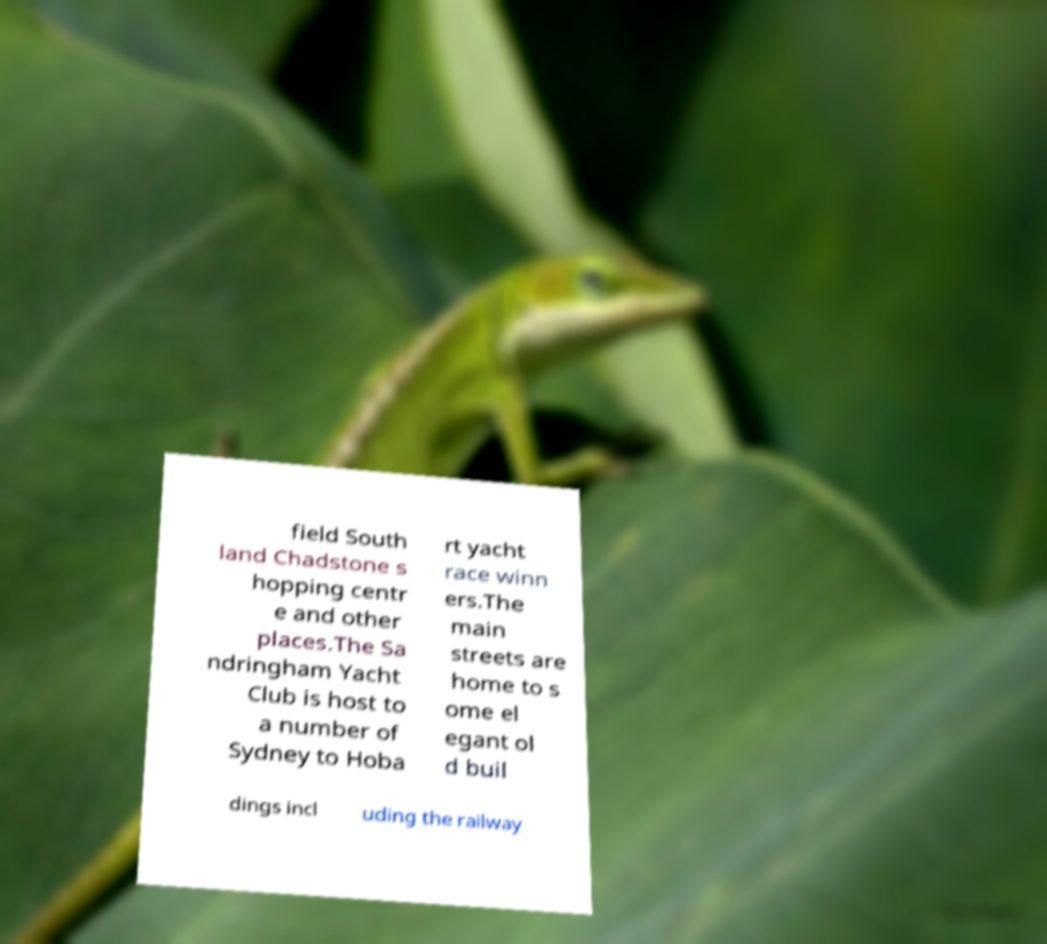I need the written content from this picture converted into text. Can you do that? field South land Chadstone s hopping centr e and other places.The Sa ndringham Yacht Club is host to a number of Sydney to Hoba rt yacht race winn ers.The main streets are home to s ome el egant ol d buil dings incl uding the railway 